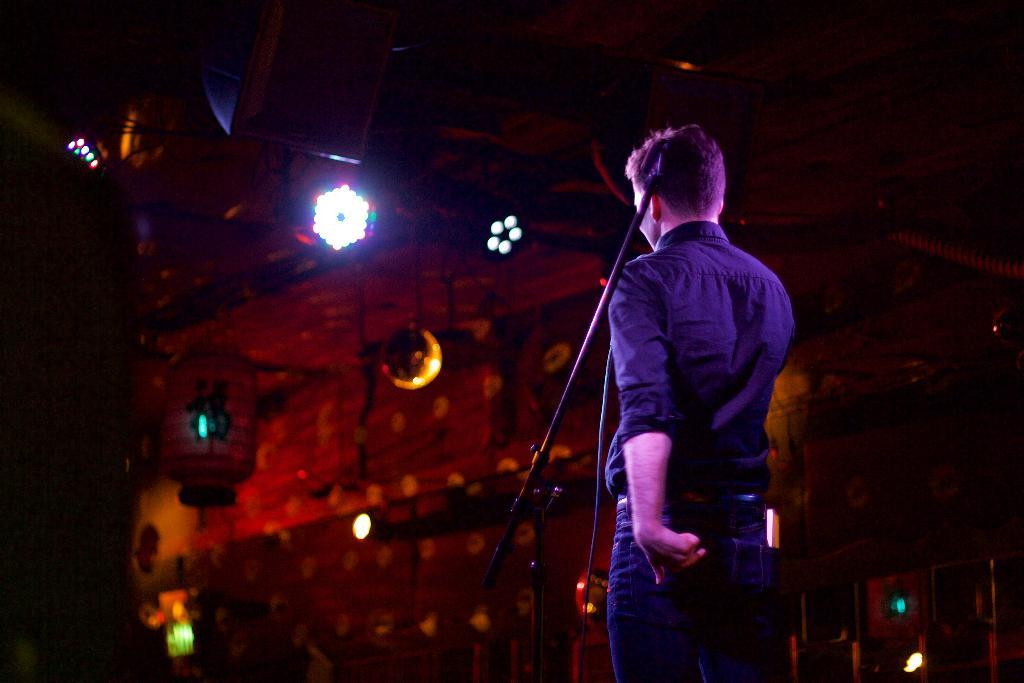What is the person in the image doing? The person is standing in front of a mic. What can be seen behind the person? There is a wall in the background of the image. Are there any additional features on the wall? Yes, there are lights on the wall in the background. What type of engine can be seen powering the plane in the image? There is no plane or engine present in the image; it features a person standing in front of a mic with a wall and lights in the background. How does the soap in the image contribute to the overall scene? There is no soap present in the image. 